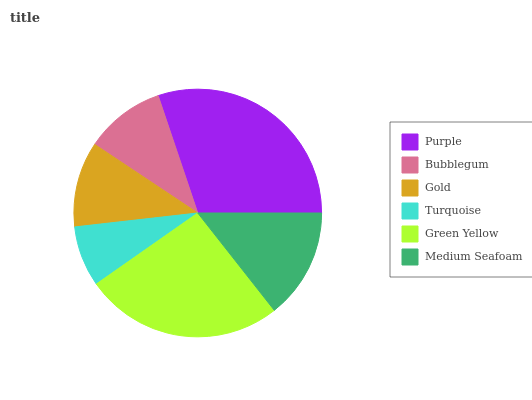Is Turquoise the minimum?
Answer yes or no. Yes. Is Purple the maximum?
Answer yes or no. Yes. Is Bubblegum the minimum?
Answer yes or no. No. Is Bubblegum the maximum?
Answer yes or no. No. Is Purple greater than Bubblegum?
Answer yes or no. Yes. Is Bubblegum less than Purple?
Answer yes or no. Yes. Is Bubblegum greater than Purple?
Answer yes or no. No. Is Purple less than Bubblegum?
Answer yes or no. No. Is Medium Seafoam the high median?
Answer yes or no. Yes. Is Gold the low median?
Answer yes or no. Yes. Is Purple the high median?
Answer yes or no. No. Is Medium Seafoam the low median?
Answer yes or no. No. 